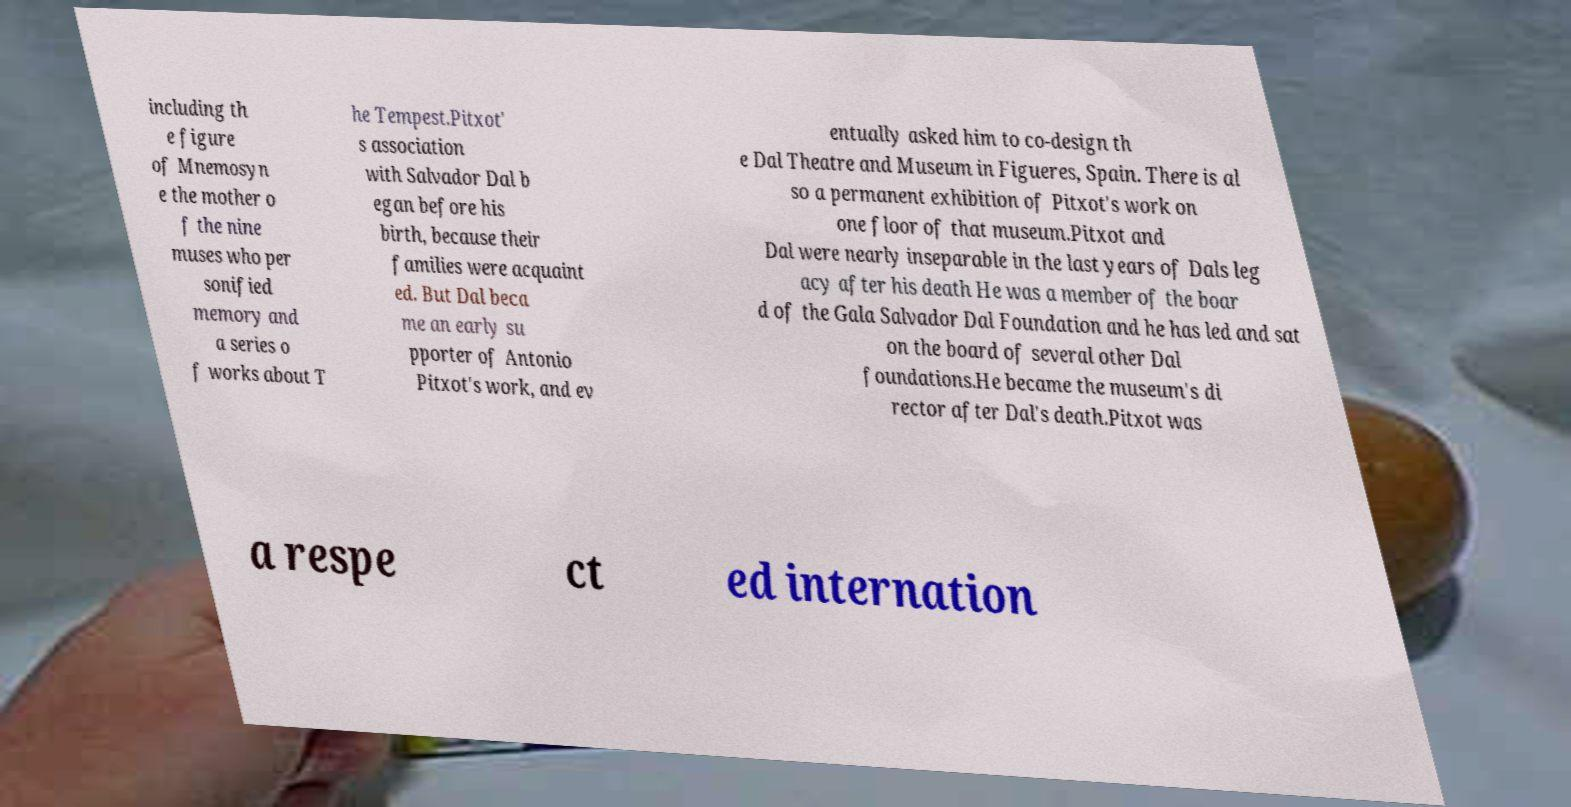I need the written content from this picture converted into text. Can you do that? including th e figure of Mnemosyn e the mother o f the nine muses who per sonified memory and a series o f works about T he Tempest.Pitxot' s association with Salvador Dal b egan before his birth, because their families were acquaint ed. But Dal beca me an early su pporter of Antonio Pitxot's work, and ev entually asked him to co-design th e Dal Theatre and Museum in Figueres, Spain. There is al so a permanent exhibition of Pitxot's work on one floor of that museum.Pitxot and Dal were nearly inseparable in the last years of Dals leg acy after his death He was a member of the boar d of the Gala Salvador Dal Foundation and he has led and sat on the board of several other Dal foundations.He became the museum's di rector after Dal's death.Pitxot was a respe ct ed internation 